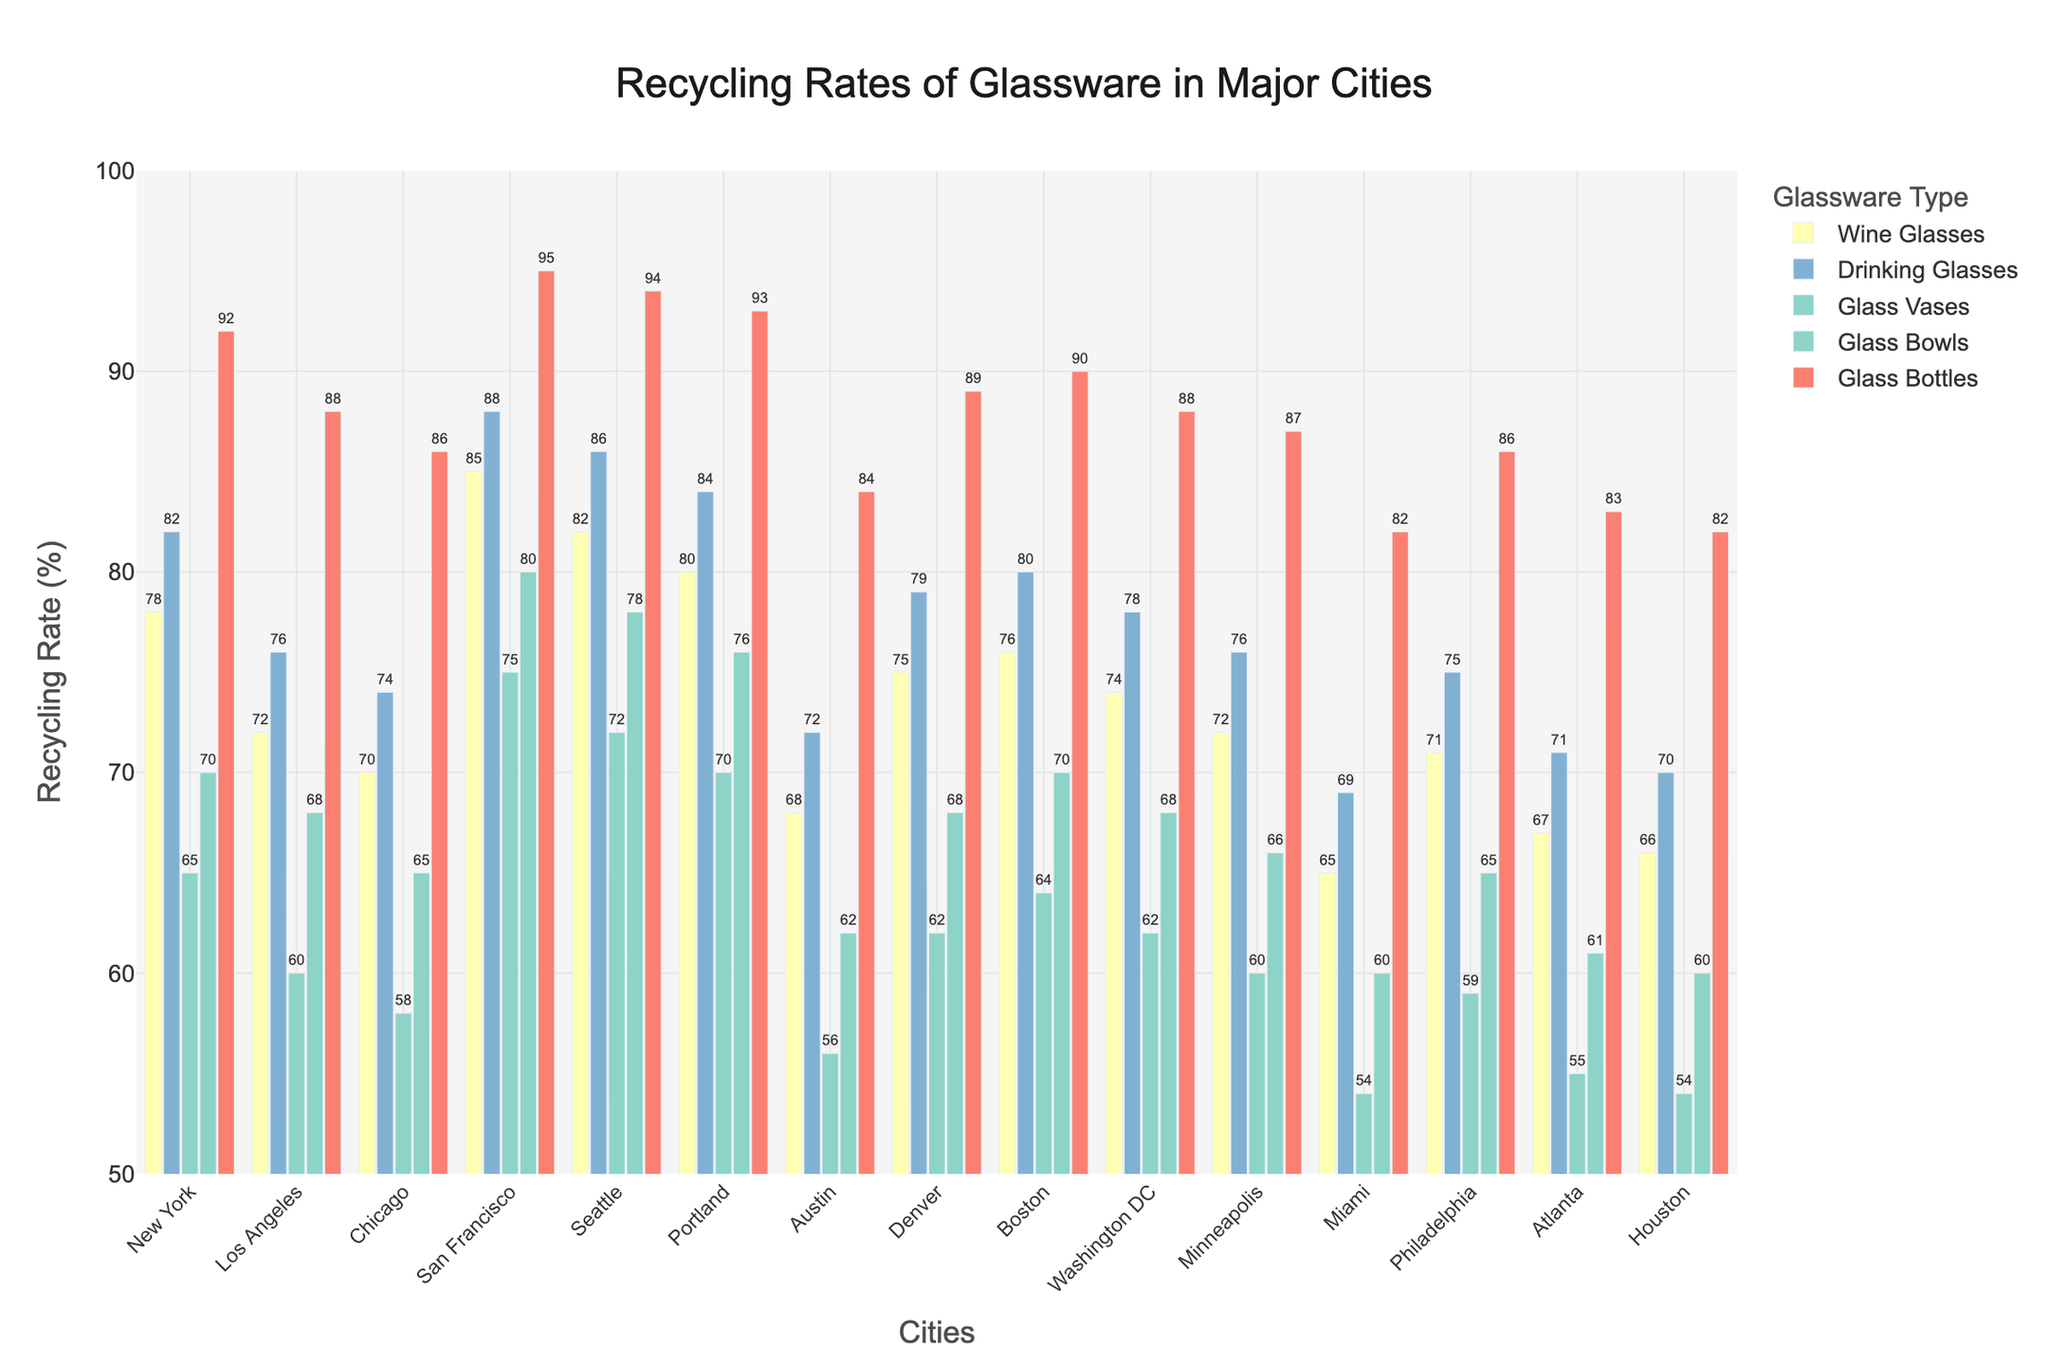What is the recycling rate of glass vases in San Francisco? Look at the "Glass Vases" bar for San Francisco and read the value from the top of the bar.
Answer: 75 Which city has the highest recycling rate for glass bottles? Compare the heights of the "Glass Bottles" bars across all cities and identify the tallest one.
Answer: San Francisco What is the difference in recycling rates for wine glasses between New York and Los Angeles? Subtract the recycling rate of wine glasses in Los Angeles from that in New York (78 - 72).
Answer: 6 Which city recycles glass bowls less, Miami or Portland? Compare the heights of the "Glass Bowls" bars for Miami and Portland, and identify the shorter one.
Answer: Miami What is the average recycling rate of drinking glasses in Chicago, Boston, and Seattle? Add the recycling rates of drinking glasses in Chicago, Boston, and Seattle, then divide by 3 (74 + 80 + 86 = 240, 240 / 3).
Answer: 80 Among the cities listed, which has the lowest recycling rate for glass bowls? Look at all the "Glass Bowls" bars and identify the shortest one.
Answer: Miami Which glassware type has the most consistent recycling rate across all cities? Visually compare the height variations of the bars for each glassware type across all cities and identify the one with the least variation.
Answer: Glass Bottles In which city is the recycling rate for drinking glasses higher than for glass bowls? Compare the heights of the "Drinking Glasses" and "Glass Bowls" bars within each city and list those where the drinking glasses bar is higher.
Answer: All cities except Los Angeles, Philadelphia, Houston, and Seattle Which city has a higher recycling rate for glass vases, Atlanta or Denver? Compare the heights of the "Glass Vases" bars for Atlanta and Denver.
Answer: Denver What is the combined recycling rate for glass bottles in New York and Washington DC? Add the recycling rates of glass bottles in New York and Washington DC (92 + 88).
Answer: 180 